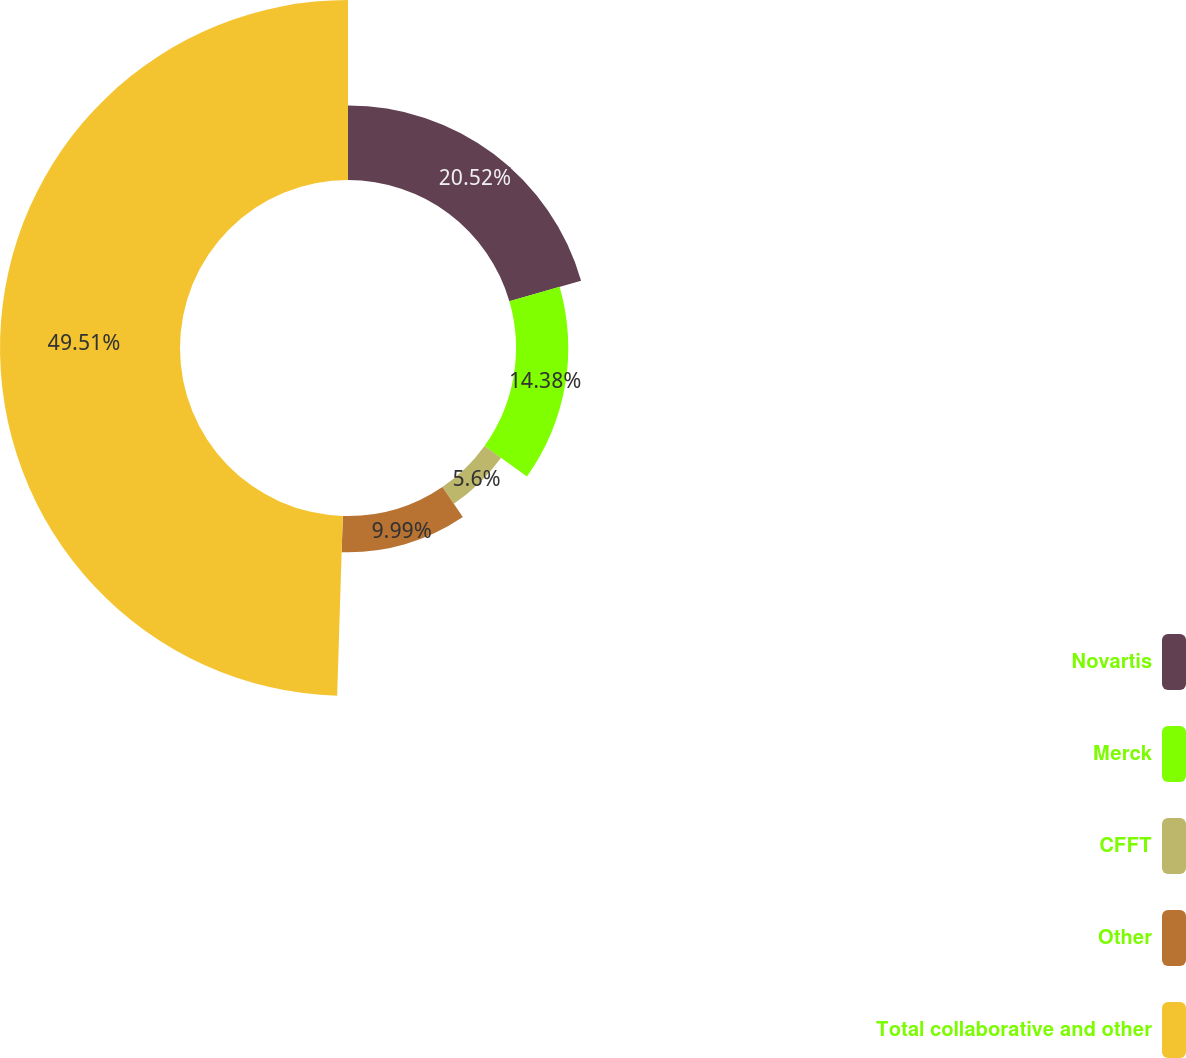Convert chart. <chart><loc_0><loc_0><loc_500><loc_500><pie_chart><fcel>Novartis<fcel>Merck<fcel>CFFT<fcel>Other<fcel>Total collaborative and other<nl><fcel>20.52%<fcel>14.38%<fcel>5.6%<fcel>9.99%<fcel>49.5%<nl></chart> 